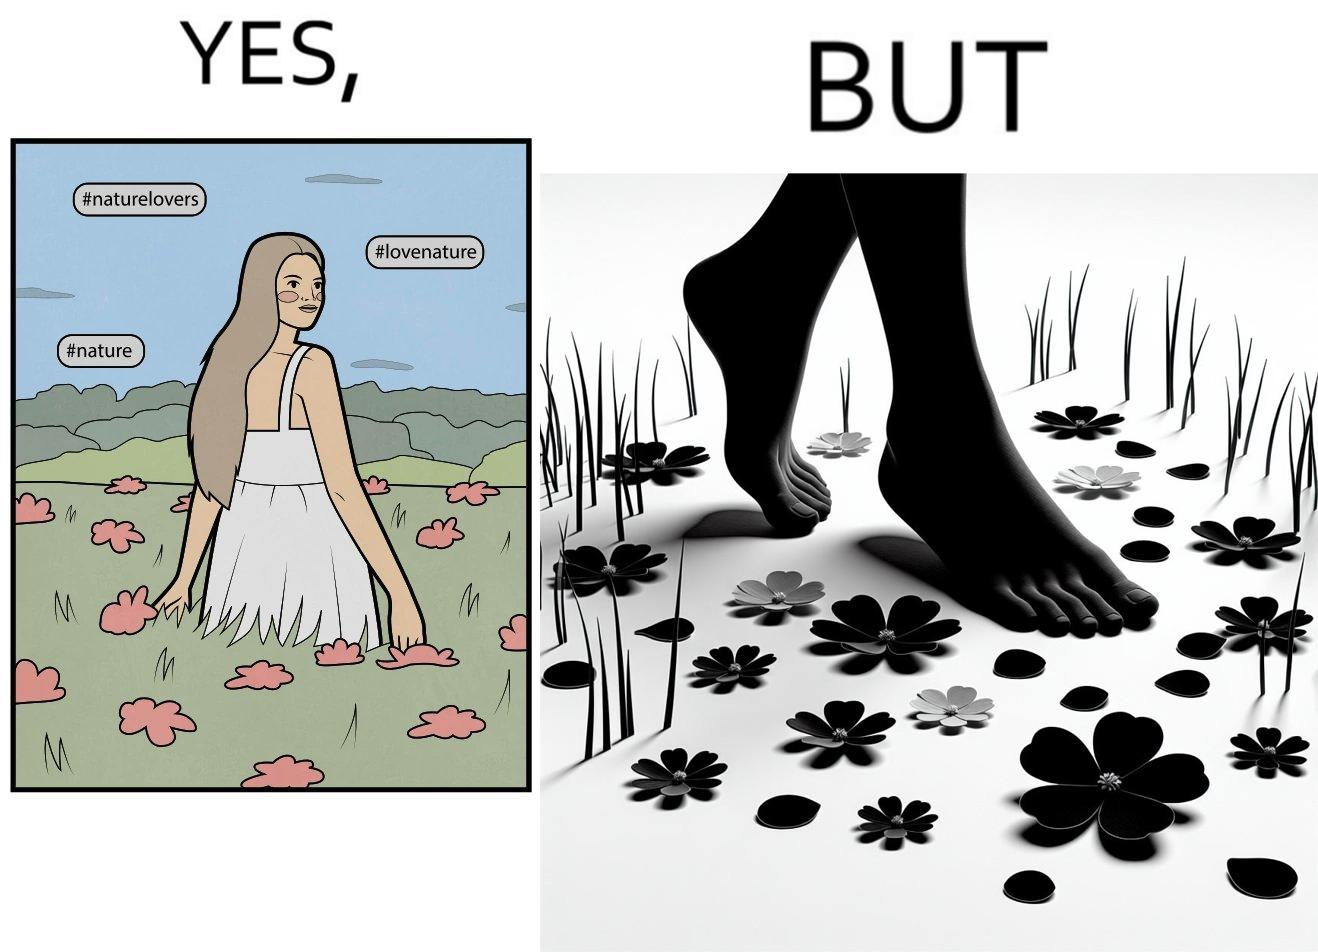Describe the contrast between the left and right parts of this image. In the left part of the image: a social media post showing a woman in a field of flowers, with hashtags such as #naturelovers, #lovenature, #nature. In the right part of the image: feet stepping on flower petals surrounded by grass. 